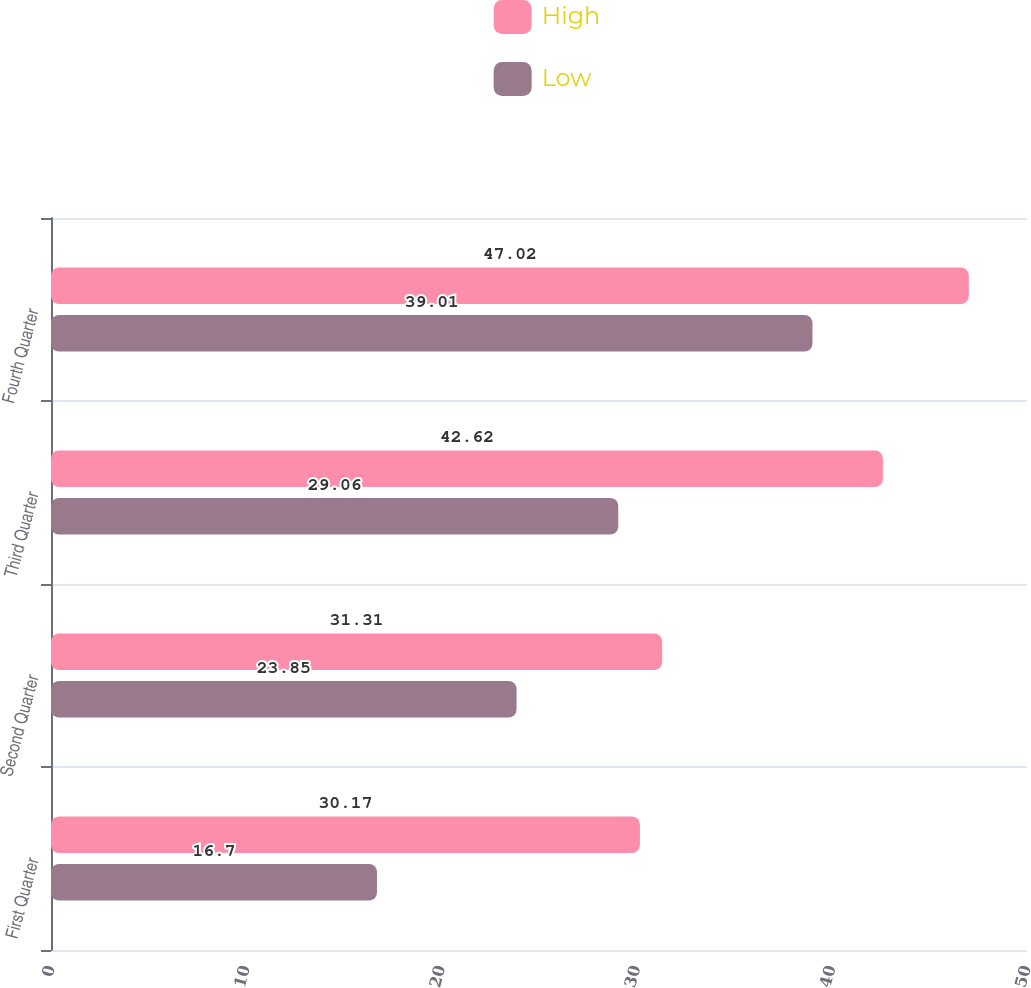Convert chart. <chart><loc_0><loc_0><loc_500><loc_500><stacked_bar_chart><ecel><fcel>First Quarter<fcel>Second Quarter<fcel>Third Quarter<fcel>Fourth Quarter<nl><fcel>High<fcel>30.17<fcel>31.31<fcel>42.62<fcel>47.02<nl><fcel>Low<fcel>16.7<fcel>23.85<fcel>29.06<fcel>39.01<nl></chart> 